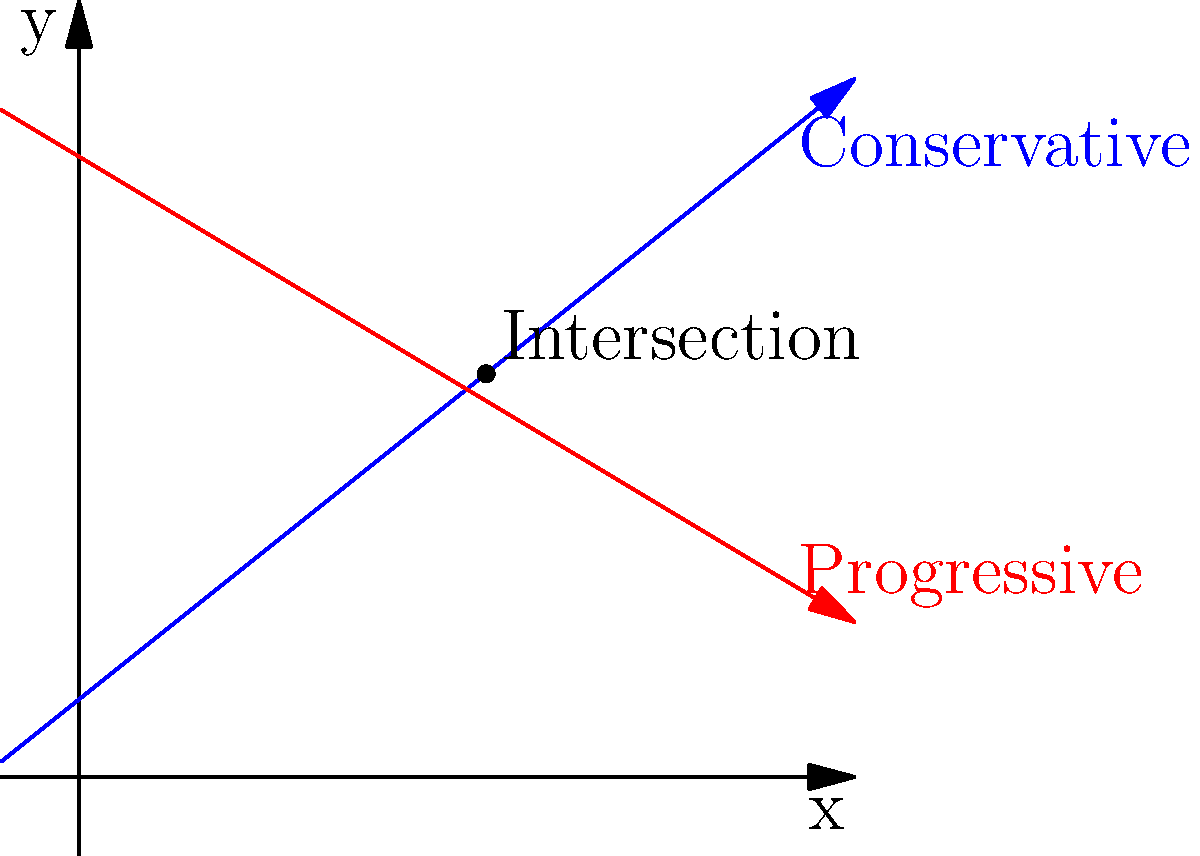In the political spectrum graph above, the blue line represents the conservative party's ideology, and the red line represents the progressive party's ideology. The x-axis represents economic policies (0 being extreme left, 10 being extreme right), while the y-axis represents social policies (0 being extremely liberal, 10 being extremely conservative). At what point do these two ideologies intersect, and what might this intersection represent in terms of political compromise? To find the intersection point of the two lines, we need to solve the system of equations represented by these lines:

1) Conservative line (blue): $y = 0.8x + 1$
2) Progressive line (red): $y = -0.6x + 8$

At the intersection point, the y-values are equal, so:

$0.8x + 1 = -0.6x + 8$

Solving this equation:

$0.8x + 0.6x = 8 - 1$
$1.4x = 7$
$x = 5$

Substituting this x-value back into either equation:

$y = 0.8(5) + 1 = 5$

Therefore, the intersection point is (5, 5).

This intersection represents a point where both parties' ideologies align, suggesting a potential area for political compromise. The x-coordinate (5) indicates a centrist economic policy, while the y-coordinate (5) suggests a moderate stance on social issues.

For a conservative politician seeking support from media personalities with similar ideologies, this intersection point could be presented as:

1) A strategic position to attract moderate voters without alienating the conservative base.
2) An opportunity to showcase willingness for bipartisan cooperation on specific issues.
3) A potential starting point for negotiations with the opposition, demonstrating leadership and pragmatism.
Answer: (5, 5) - represents a centrist economic and social policy position where conservative and progressive ideologies intersect, offering potential for political compromise. 